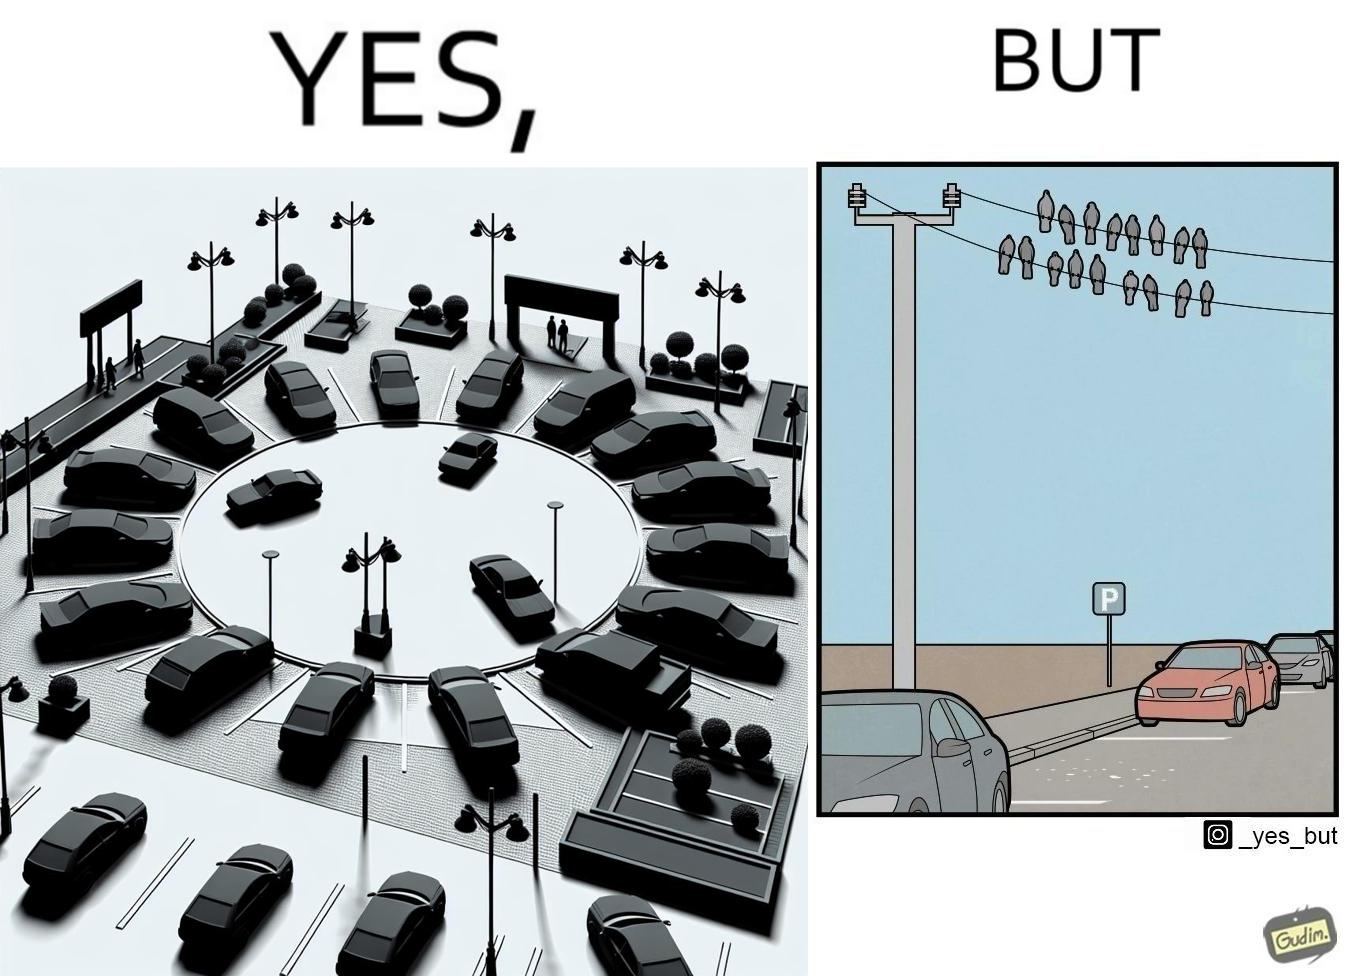Explain the humor or irony in this image. The image is ironical such that although there is a place for parking but that place is not suitable because if we place our car there then our car will become dirty from top due to crow beet. 